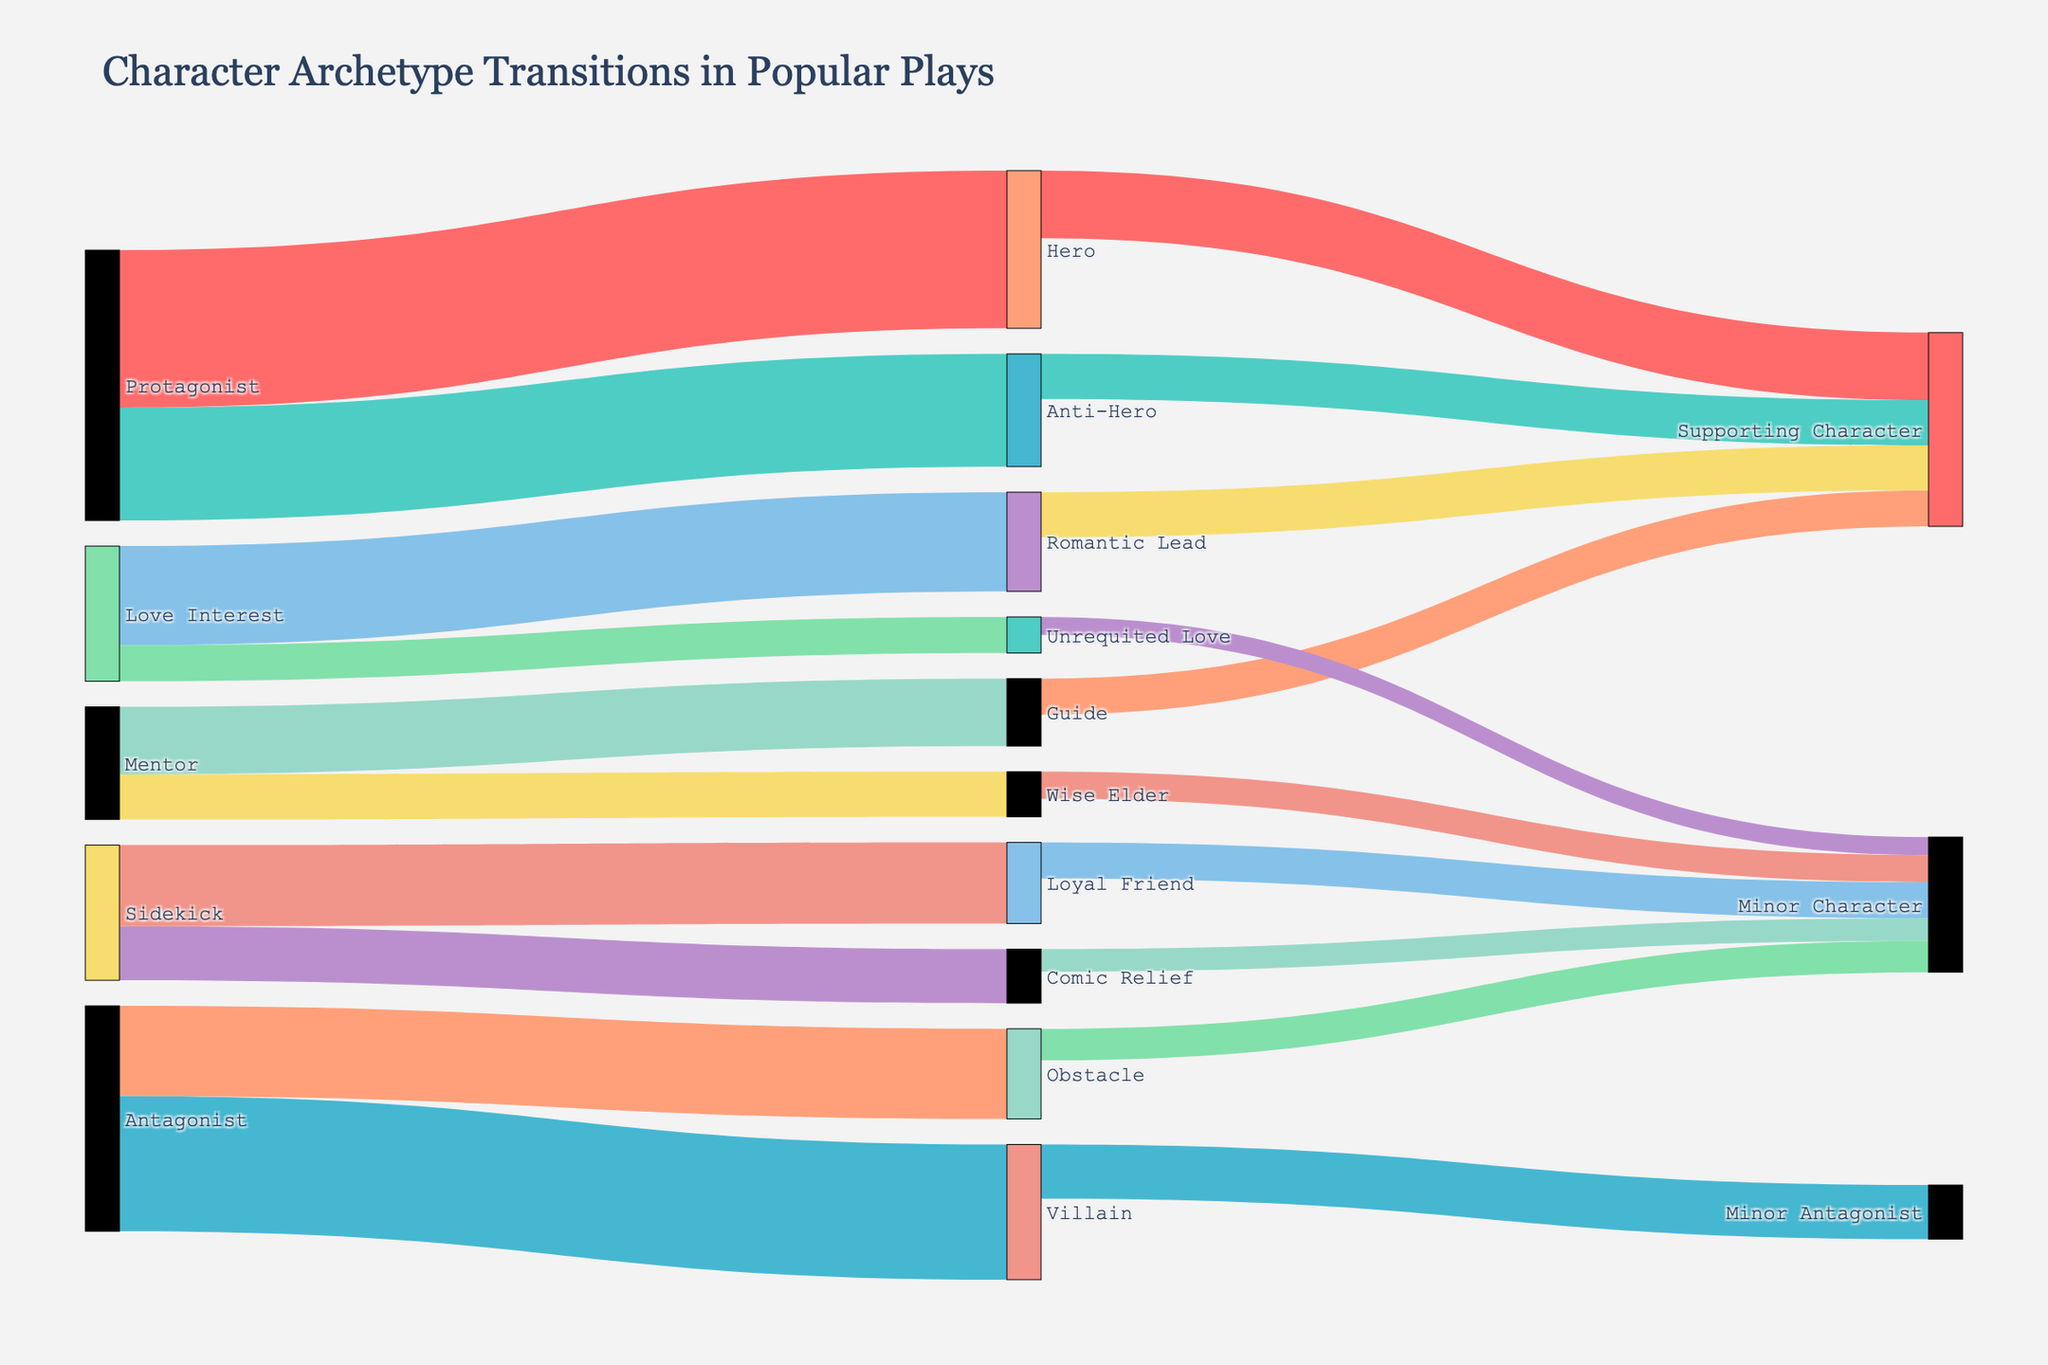1. What is the title of the Sankey diagram? The title of the Sankey diagram is written at the top of the figure.
Answer: Character Archetype Transitions in Popular Plays 2. How many character archetypes transition into the "Supporting Character" role? By examining the target labels to "Supporting Character", we see transitions from Hero, Anti-Hero, Guide, and Romantic Lead, thus 4 distinct archetypes.
Answer: 4 3. What is the total value of transitions originating from the "Protagonist"? The Sankey diagram shows transitions of 35 to Hero and 25 to Anti-Hero from Protagonist. Summing these values gives 35 + 25 = 60.
Answer: 60 4. Which character archetype received the highest number of transitions to "Minor Character"? Looking at the target labels to "Minor Character", we sum the values from each source: Comic Relief (5), Unrequited Love (4), Wise Elder (6), Loyal Friend (8), and Obstacle (7). Loyal Friend has the highest value of 8.
Answer: Loyal Friend 5. Are there more transitions from "Sidekick" to "Minor Character" or from "Villain" to "Minor Antagonist"? Observing the value of transitions from Sidekick to Minor Character is 8; from Villain to Minor Antagonist is 12. 12 is greater than 8.
Answer: Villain to Minor Antagonist 6. What are the combined transitions values for roles originating from "Love Interest"? From Love Interest, we see transitions to Romantic Lead (22) and Unrequited Love (8), summing up to 22 + 8 = 30.
Answer: 30 7. Compare the number of transitions between the "Mentor" archetypes to "Guide" and "Wise Elder". Which is greater? The number of transitions from Mentor to Guide is 15, whereas from Mentor to Wise Elder is 10. 15 is greater than 10.
Answer: Guide 8. What is the average value of transitions to "Supporting Character"? The transitions to Supporting Character from Hero (15), Anti-Hero (10), Guide (8), and Romantic Lead (10). The sum is 15 + 10 + 8 + 10 = 43, and the average is 43 / 4 = 10.75.
Answer: 10.75 9. How many character archetypes contribute to the "Villain" role in the diagram, and what are their origins? No archetypes contribute to the Villain target directly; the values only originate from Villain itself to Minor Antagonist. Therefore, the answer is zero and no origins.
Answer: 0 10. What archetypes transition to the "Hero", and what is their combined value? The Protagonist transitions into Hero with a value of 35. Therefore, only Protagonist transitions to Hero, and the value is 35.
Answer: 35 